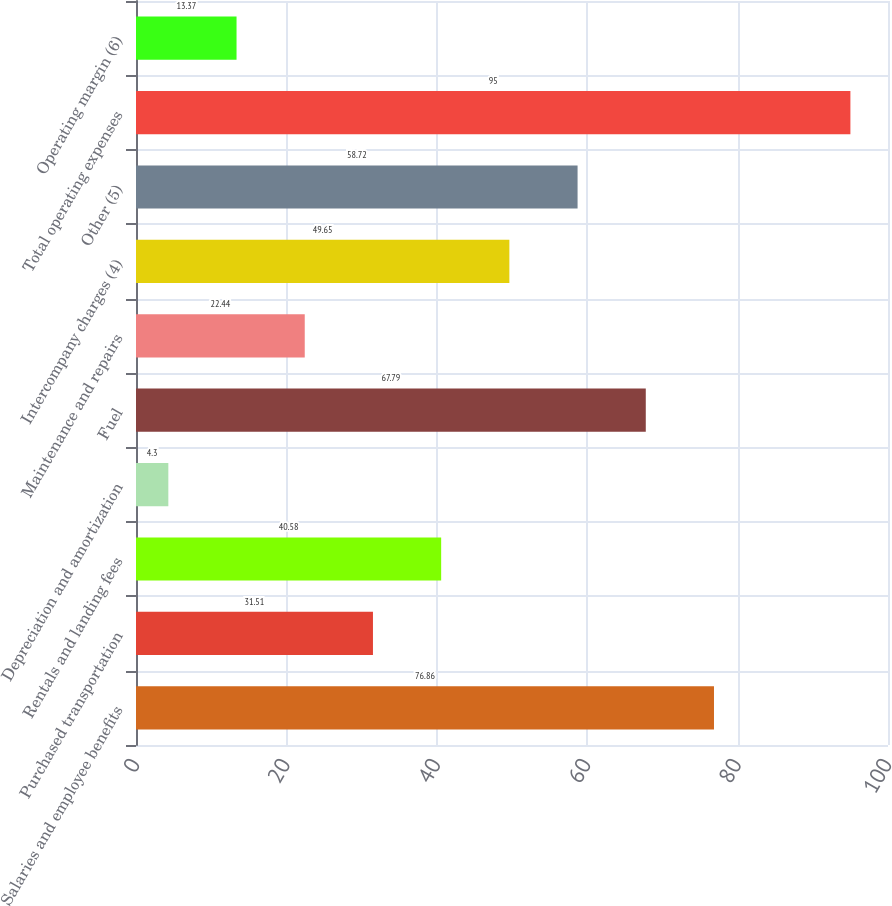<chart> <loc_0><loc_0><loc_500><loc_500><bar_chart><fcel>Salaries and employee benefits<fcel>Purchased transportation<fcel>Rentals and landing fees<fcel>Depreciation and amortization<fcel>Fuel<fcel>Maintenance and repairs<fcel>Intercompany charges (4)<fcel>Other (5)<fcel>Total operating expenses<fcel>Operating margin (6)<nl><fcel>76.86<fcel>31.51<fcel>40.58<fcel>4.3<fcel>67.79<fcel>22.44<fcel>49.65<fcel>58.72<fcel>95<fcel>13.37<nl></chart> 